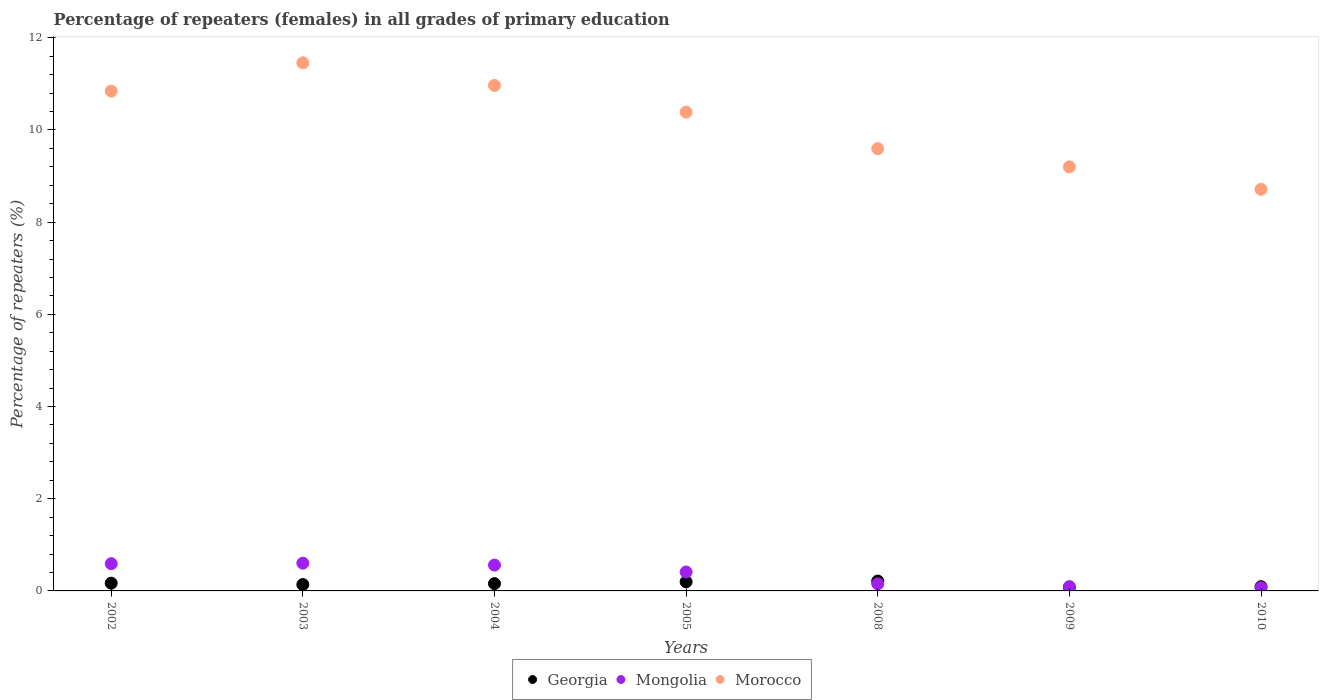Is the number of dotlines equal to the number of legend labels?
Provide a succinct answer. Yes. What is the percentage of repeaters (females) in Mongolia in 2010?
Your answer should be very brief. 0.07. Across all years, what is the maximum percentage of repeaters (females) in Morocco?
Your answer should be very brief. 11.46. Across all years, what is the minimum percentage of repeaters (females) in Georgia?
Your response must be concise. 0.07. What is the total percentage of repeaters (females) in Morocco in the graph?
Your response must be concise. 71.16. What is the difference between the percentage of repeaters (females) in Mongolia in 2005 and that in 2009?
Give a very brief answer. 0.32. What is the difference between the percentage of repeaters (females) in Mongolia in 2005 and the percentage of repeaters (females) in Georgia in 2010?
Offer a terse response. 0.32. What is the average percentage of repeaters (females) in Mongolia per year?
Make the answer very short. 0.35. In the year 2005, what is the difference between the percentage of repeaters (females) in Morocco and percentage of repeaters (females) in Mongolia?
Offer a terse response. 9.98. In how many years, is the percentage of repeaters (females) in Mongolia greater than 8.8 %?
Keep it short and to the point. 0. What is the ratio of the percentage of repeaters (females) in Morocco in 2002 to that in 2010?
Offer a very short reply. 1.24. Is the difference between the percentage of repeaters (females) in Morocco in 2004 and 2010 greater than the difference between the percentage of repeaters (females) in Mongolia in 2004 and 2010?
Your response must be concise. Yes. What is the difference between the highest and the second highest percentage of repeaters (females) in Mongolia?
Offer a very short reply. 0.01. What is the difference between the highest and the lowest percentage of repeaters (females) in Mongolia?
Make the answer very short. 0.53. Does the percentage of repeaters (females) in Georgia monotonically increase over the years?
Give a very brief answer. No. Is the percentage of repeaters (females) in Mongolia strictly less than the percentage of repeaters (females) in Georgia over the years?
Offer a terse response. No. How many dotlines are there?
Offer a terse response. 3. How many years are there in the graph?
Your answer should be very brief. 7. Does the graph contain any zero values?
Offer a very short reply. No. How many legend labels are there?
Offer a terse response. 3. What is the title of the graph?
Your answer should be very brief. Percentage of repeaters (females) in all grades of primary education. Does "Iraq" appear as one of the legend labels in the graph?
Provide a short and direct response. No. What is the label or title of the Y-axis?
Your response must be concise. Percentage of repeaters (%). What is the Percentage of repeaters (%) of Georgia in 2002?
Your response must be concise. 0.17. What is the Percentage of repeaters (%) in Mongolia in 2002?
Offer a very short reply. 0.59. What is the Percentage of repeaters (%) of Morocco in 2002?
Provide a succinct answer. 10.84. What is the Percentage of repeaters (%) in Georgia in 2003?
Give a very brief answer. 0.14. What is the Percentage of repeaters (%) of Mongolia in 2003?
Offer a terse response. 0.6. What is the Percentage of repeaters (%) of Morocco in 2003?
Provide a succinct answer. 11.46. What is the Percentage of repeaters (%) in Georgia in 2004?
Offer a very short reply. 0.16. What is the Percentage of repeaters (%) of Mongolia in 2004?
Provide a succinct answer. 0.56. What is the Percentage of repeaters (%) of Morocco in 2004?
Offer a very short reply. 10.97. What is the Percentage of repeaters (%) in Georgia in 2005?
Your answer should be very brief. 0.2. What is the Percentage of repeaters (%) of Mongolia in 2005?
Provide a short and direct response. 0.41. What is the Percentage of repeaters (%) of Morocco in 2005?
Provide a succinct answer. 10.39. What is the Percentage of repeaters (%) in Georgia in 2008?
Your answer should be compact. 0.21. What is the Percentage of repeaters (%) in Mongolia in 2008?
Ensure brevity in your answer.  0.15. What is the Percentage of repeaters (%) of Morocco in 2008?
Give a very brief answer. 9.6. What is the Percentage of repeaters (%) of Georgia in 2009?
Offer a terse response. 0.07. What is the Percentage of repeaters (%) of Mongolia in 2009?
Your answer should be very brief. 0.09. What is the Percentage of repeaters (%) of Morocco in 2009?
Your response must be concise. 9.2. What is the Percentage of repeaters (%) in Georgia in 2010?
Offer a terse response. 0.09. What is the Percentage of repeaters (%) of Mongolia in 2010?
Ensure brevity in your answer.  0.07. What is the Percentage of repeaters (%) of Morocco in 2010?
Offer a very short reply. 8.71. Across all years, what is the maximum Percentage of repeaters (%) of Georgia?
Keep it short and to the point. 0.21. Across all years, what is the maximum Percentage of repeaters (%) of Mongolia?
Provide a succinct answer. 0.6. Across all years, what is the maximum Percentage of repeaters (%) in Morocco?
Provide a succinct answer. 11.46. Across all years, what is the minimum Percentage of repeaters (%) of Georgia?
Your response must be concise. 0.07. Across all years, what is the minimum Percentage of repeaters (%) of Mongolia?
Offer a terse response. 0.07. Across all years, what is the minimum Percentage of repeaters (%) of Morocco?
Keep it short and to the point. 8.71. What is the total Percentage of repeaters (%) of Georgia in the graph?
Give a very brief answer. 1.04. What is the total Percentage of repeaters (%) in Mongolia in the graph?
Give a very brief answer. 2.48. What is the total Percentage of repeaters (%) of Morocco in the graph?
Make the answer very short. 71.16. What is the difference between the Percentage of repeaters (%) in Georgia in 2002 and that in 2003?
Provide a short and direct response. 0.03. What is the difference between the Percentage of repeaters (%) in Mongolia in 2002 and that in 2003?
Your answer should be compact. -0.01. What is the difference between the Percentage of repeaters (%) in Morocco in 2002 and that in 2003?
Offer a very short reply. -0.61. What is the difference between the Percentage of repeaters (%) of Mongolia in 2002 and that in 2004?
Make the answer very short. 0.03. What is the difference between the Percentage of repeaters (%) in Morocco in 2002 and that in 2004?
Your answer should be very brief. -0.12. What is the difference between the Percentage of repeaters (%) in Georgia in 2002 and that in 2005?
Ensure brevity in your answer.  -0.03. What is the difference between the Percentage of repeaters (%) in Mongolia in 2002 and that in 2005?
Provide a short and direct response. 0.18. What is the difference between the Percentage of repeaters (%) in Morocco in 2002 and that in 2005?
Offer a very short reply. 0.46. What is the difference between the Percentage of repeaters (%) in Georgia in 2002 and that in 2008?
Offer a terse response. -0.05. What is the difference between the Percentage of repeaters (%) in Mongolia in 2002 and that in 2008?
Provide a succinct answer. 0.44. What is the difference between the Percentage of repeaters (%) of Morocco in 2002 and that in 2008?
Give a very brief answer. 1.25. What is the difference between the Percentage of repeaters (%) of Georgia in 2002 and that in 2009?
Your response must be concise. 0.09. What is the difference between the Percentage of repeaters (%) in Mongolia in 2002 and that in 2009?
Provide a short and direct response. 0.5. What is the difference between the Percentage of repeaters (%) of Morocco in 2002 and that in 2009?
Your answer should be very brief. 1.64. What is the difference between the Percentage of repeaters (%) in Georgia in 2002 and that in 2010?
Give a very brief answer. 0.08. What is the difference between the Percentage of repeaters (%) in Mongolia in 2002 and that in 2010?
Offer a terse response. 0.52. What is the difference between the Percentage of repeaters (%) of Morocco in 2002 and that in 2010?
Keep it short and to the point. 2.13. What is the difference between the Percentage of repeaters (%) of Georgia in 2003 and that in 2004?
Make the answer very short. -0.02. What is the difference between the Percentage of repeaters (%) in Mongolia in 2003 and that in 2004?
Offer a very short reply. 0.04. What is the difference between the Percentage of repeaters (%) in Morocco in 2003 and that in 2004?
Provide a short and direct response. 0.49. What is the difference between the Percentage of repeaters (%) of Georgia in 2003 and that in 2005?
Provide a succinct answer. -0.06. What is the difference between the Percentage of repeaters (%) of Mongolia in 2003 and that in 2005?
Offer a very short reply. 0.19. What is the difference between the Percentage of repeaters (%) of Morocco in 2003 and that in 2005?
Your response must be concise. 1.07. What is the difference between the Percentage of repeaters (%) in Georgia in 2003 and that in 2008?
Ensure brevity in your answer.  -0.08. What is the difference between the Percentage of repeaters (%) of Mongolia in 2003 and that in 2008?
Ensure brevity in your answer.  0.45. What is the difference between the Percentage of repeaters (%) of Morocco in 2003 and that in 2008?
Your answer should be very brief. 1.86. What is the difference between the Percentage of repeaters (%) of Georgia in 2003 and that in 2009?
Make the answer very short. 0.06. What is the difference between the Percentage of repeaters (%) of Mongolia in 2003 and that in 2009?
Offer a very short reply. 0.51. What is the difference between the Percentage of repeaters (%) of Morocco in 2003 and that in 2009?
Offer a very short reply. 2.26. What is the difference between the Percentage of repeaters (%) of Georgia in 2003 and that in 2010?
Offer a very short reply. 0.05. What is the difference between the Percentage of repeaters (%) of Mongolia in 2003 and that in 2010?
Ensure brevity in your answer.  0.53. What is the difference between the Percentage of repeaters (%) of Morocco in 2003 and that in 2010?
Make the answer very short. 2.74. What is the difference between the Percentage of repeaters (%) of Georgia in 2004 and that in 2005?
Give a very brief answer. -0.04. What is the difference between the Percentage of repeaters (%) of Mongolia in 2004 and that in 2005?
Keep it short and to the point. 0.15. What is the difference between the Percentage of repeaters (%) of Morocco in 2004 and that in 2005?
Offer a terse response. 0.58. What is the difference between the Percentage of repeaters (%) of Georgia in 2004 and that in 2008?
Ensure brevity in your answer.  -0.06. What is the difference between the Percentage of repeaters (%) in Mongolia in 2004 and that in 2008?
Your response must be concise. 0.41. What is the difference between the Percentage of repeaters (%) of Morocco in 2004 and that in 2008?
Your response must be concise. 1.37. What is the difference between the Percentage of repeaters (%) in Georgia in 2004 and that in 2009?
Your answer should be compact. 0.08. What is the difference between the Percentage of repeaters (%) in Mongolia in 2004 and that in 2009?
Your answer should be very brief. 0.47. What is the difference between the Percentage of repeaters (%) in Morocco in 2004 and that in 2009?
Your answer should be compact. 1.77. What is the difference between the Percentage of repeaters (%) of Georgia in 2004 and that in 2010?
Keep it short and to the point. 0.07. What is the difference between the Percentage of repeaters (%) of Mongolia in 2004 and that in 2010?
Provide a short and direct response. 0.49. What is the difference between the Percentage of repeaters (%) of Morocco in 2004 and that in 2010?
Offer a very short reply. 2.25. What is the difference between the Percentage of repeaters (%) in Georgia in 2005 and that in 2008?
Keep it short and to the point. -0.02. What is the difference between the Percentage of repeaters (%) in Mongolia in 2005 and that in 2008?
Make the answer very short. 0.26. What is the difference between the Percentage of repeaters (%) of Morocco in 2005 and that in 2008?
Give a very brief answer. 0.79. What is the difference between the Percentage of repeaters (%) of Georgia in 2005 and that in 2009?
Provide a succinct answer. 0.12. What is the difference between the Percentage of repeaters (%) of Mongolia in 2005 and that in 2009?
Offer a terse response. 0.32. What is the difference between the Percentage of repeaters (%) of Morocco in 2005 and that in 2009?
Your response must be concise. 1.19. What is the difference between the Percentage of repeaters (%) in Georgia in 2005 and that in 2010?
Give a very brief answer. 0.11. What is the difference between the Percentage of repeaters (%) in Mongolia in 2005 and that in 2010?
Your answer should be compact. 0.34. What is the difference between the Percentage of repeaters (%) of Morocco in 2005 and that in 2010?
Offer a very short reply. 1.67. What is the difference between the Percentage of repeaters (%) of Georgia in 2008 and that in 2009?
Your response must be concise. 0.14. What is the difference between the Percentage of repeaters (%) in Mongolia in 2008 and that in 2009?
Keep it short and to the point. 0.06. What is the difference between the Percentage of repeaters (%) of Morocco in 2008 and that in 2009?
Ensure brevity in your answer.  0.4. What is the difference between the Percentage of repeaters (%) of Georgia in 2008 and that in 2010?
Make the answer very short. 0.12. What is the difference between the Percentage of repeaters (%) of Mongolia in 2008 and that in 2010?
Your answer should be compact. 0.08. What is the difference between the Percentage of repeaters (%) in Morocco in 2008 and that in 2010?
Your response must be concise. 0.88. What is the difference between the Percentage of repeaters (%) of Georgia in 2009 and that in 2010?
Your response must be concise. -0.02. What is the difference between the Percentage of repeaters (%) in Mongolia in 2009 and that in 2010?
Offer a terse response. 0.03. What is the difference between the Percentage of repeaters (%) of Morocco in 2009 and that in 2010?
Your answer should be very brief. 0.49. What is the difference between the Percentage of repeaters (%) in Georgia in 2002 and the Percentage of repeaters (%) in Mongolia in 2003?
Make the answer very short. -0.43. What is the difference between the Percentage of repeaters (%) of Georgia in 2002 and the Percentage of repeaters (%) of Morocco in 2003?
Keep it short and to the point. -11.29. What is the difference between the Percentage of repeaters (%) of Mongolia in 2002 and the Percentage of repeaters (%) of Morocco in 2003?
Provide a short and direct response. -10.86. What is the difference between the Percentage of repeaters (%) in Georgia in 2002 and the Percentage of repeaters (%) in Mongolia in 2004?
Give a very brief answer. -0.39. What is the difference between the Percentage of repeaters (%) in Georgia in 2002 and the Percentage of repeaters (%) in Morocco in 2004?
Keep it short and to the point. -10.8. What is the difference between the Percentage of repeaters (%) in Mongolia in 2002 and the Percentage of repeaters (%) in Morocco in 2004?
Offer a very short reply. -10.37. What is the difference between the Percentage of repeaters (%) of Georgia in 2002 and the Percentage of repeaters (%) of Mongolia in 2005?
Provide a succinct answer. -0.24. What is the difference between the Percentage of repeaters (%) in Georgia in 2002 and the Percentage of repeaters (%) in Morocco in 2005?
Your answer should be very brief. -10.22. What is the difference between the Percentage of repeaters (%) of Mongolia in 2002 and the Percentage of repeaters (%) of Morocco in 2005?
Provide a short and direct response. -9.8. What is the difference between the Percentage of repeaters (%) of Georgia in 2002 and the Percentage of repeaters (%) of Mongolia in 2008?
Make the answer very short. 0.01. What is the difference between the Percentage of repeaters (%) of Georgia in 2002 and the Percentage of repeaters (%) of Morocco in 2008?
Your answer should be very brief. -9.43. What is the difference between the Percentage of repeaters (%) in Mongolia in 2002 and the Percentage of repeaters (%) in Morocco in 2008?
Provide a short and direct response. -9. What is the difference between the Percentage of repeaters (%) of Georgia in 2002 and the Percentage of repeaters (%) of Mongolia in 2009?
Give a very brief answer. 0.07. What is the difference between the Percentage of repeaters (%) of Georgia in 2002 and the Percentage of repeaters (%) of Morocco in 2009?
Make the answer very short. -9.03. What is the difference between the Percentage of repeaters (%) in Mongolia in 2002 and the Percentage of repeaters (%) in Morocco in 2009?
Offer a very short reply. -8.61. What is the difference between the Percentage of repeaters (%) of Georgia in 2002 and the Percentage of repeaters (%) of Mongolia in 2010?
Your answer should be compact. 0.1. What is the difference between the Percentage of repeaters (%) of Georgia in 2002 and the Percentage of repeaters (%) of Morocco in 2010?
Provide a short and direct response. -8.54. What is the difference between the Percentage of repeaters (%) of Mongolia in 2002 and the Percentage of repeaters (%) of Morocco in 2010?
Ensure brevity in your answer.  -8.12. What is the difference between the Percentage of repeaters (%) of Georgia in 2003 and the Percentage of repeaters (%) of Mongolia in 2004?
Make the answer very short. -0.42. What is the difference between the Percentage of repeaters (%) of Georgia in 2003 and the Percentage of repeaters (%) of Morocco in 2004?
Your answer should be very brief. -10.83. What is the difference between the Percentage of repeaters (%) in Mongolia in 2003 and the Percentage of repeaters (%) in Morocco in 2004?
Provide a succinct answer. -10.36. What is the difference between the Percentage of repeaters (%) of Georgia in 2003 and the Percentage of repeaters (%) of Mongolia in 2005?
Ensure brevity in your answer.  -0.27. What is the difference between the Percentage of repeaters (%) of Georgia in 2003 and the Percentage of repeaters (%) of Morocco in 2005?
Make the answer very short. -10.25. What is the difference between the Percentage of repeaters (%) in Mongolia in 2003 and the Percentage of repeaters (%) in Morocco in 2005?
Keep it short and to the point. -9.78. What is the difference between the Percentage of repeaters (%) in Georgia in 2003 and the Percentage of repeaters (%) in Mongolia in 2008?
Ensure brevity in your answer.  -0.01. What is the difference between the Percentage of repeaters (%) of Georgia in 2003 and the Percentage of repeaters (%) of Morocco in 2008?
Give a very brief answer. -9.46. What is the difference between the Percentage of repeaters (%) of Mongolia in 2003 and the Percentage of repeaters (%) of Morocco in 2008?
Make the answer very short. -8.99. What is the difference between the Percentage of repeaters (%) of Georgia in 2003 and the Percentage of repeaters (%) of Mongolia in 2009?
Your answer should be compact. 0.04. What is the difference between the Percentage of repeaters (%) in Georgia in 2003 and the Percentage of repeaters (%) in Morocco in 2009?
Offer a terse response. -9.06. What is the difference between the Percentage of repeaters (%) of Mongolia in 2003 and the Percentage of repeaters (%) of Morocco in 2009?
Offer a terse response. -8.6. What is the difference between the Percentage of repeaters (%) of Georgia in 2003 and the Percentage of repeaters (%) of Mongolia in 2010?
Your answer should be compact. 0.07. What is the difference between the Percentage of repeaters (%) in Georgia in 2003 and the Percentage of repeaters (%) in Morocco in 2010?
Keep it short and to the point. -8.57. What is the difference between the Percentage of repeaters (%) of Mongolia in 2003 and the Percentage of repeaters (%) of Morocco in 2010?
Ensure brevity in your answer.  -8.11. What is the difference between the Percentage of repeaters (%) in Georgia in 2004 and the Percentage of repeaters (%) in Mongolia in 2005?
Provide a succinct answer. -0.25. What is the difference between the Percentage of repeaters (%) of Georgia in 2004 and the Percentage of repeaters (%) of Morocco in 2005?
Your response must be concise. -10.23. What is the difference between the Percentage of repeaters (%) in Mongolia in 2004 and the Percentage of repeaters (%) in Morocco in 2005?
Provide a short and direct response. -9.83. What is the difference between the Percentage of repeaters (%) in Georgia in 2004 and the Percentage of repeaters (%) in Mongolia in 2008?
Give a very brief answer. 0.01. What is the difference between the Percentage of repeaters (%) in Georgia in 2004 and the Percentage of repeaters (%) in Morocco in 2008?
Offer a terse response. -9.44. What is the difference between the Percentage of repeaters (%) in Mongolia in 2004 and the Percentage of repeaters (%) in Morocco in 2008?
Make the answer very short. -9.03. What is the difference between the Percentage of repeaters (%) in Georgia in 2004 and the Percentage of repeaters (%) in Mongolia in 2009?
Your response must be concise. 0.06. What is the difference between the Percentage of repeaters (%) of Georgia in 2004 and the Percentage of repeaters (%) of Morocco in 2009?
Your answer should be compact. -9.04. What is the difference between the Percentage of repeaters (%) of Mongolia in 2004 and the Percentage of repeaters (%) of Morocco in 2009?
Provide a short and direct response. -8.64. What is the difference between the Percentage of repeaters (%) in Georgia in 2004 and the Percentage of repeaters (%) in Mongolia in 2010?
Give a very brief answer. 0.09. What is the difference between the Percentage of repeaters (%) in Georgia in 2004 and the Percentage of repeaters (%) in Morocco in 2010?
Keep it short and to the point. -8.55. What is the difference between the Percentage of repeaters (%) of Mongolia in 2004 and the Percentage of repeaters (%) of Morocco in 2010?
Provide a short and direct response. -8.15. What is the difference between the Percentage of repeaters (%) in Georgia in 2005 and the Percentage of repeaters (%) in Mongolia in 2008?
Make the answer very short. 0.04. What is the difference between the Percentage of repeaters (%) of Georgia in 2005 and the Percentage of repeaters (%) of Morocco in 2008?
Keep it short and to the point. -9.4. What is the difference between the Percentage of repeaters (%) of Mongolia in 2005 and the Percentage of repeaters (%) of Morocco in 2008?
Keep it short and to the point. -9.18. What is the difference between the Percentage of repeaters (%) in Georgia in 2005 and the Percentage of repeaters (%) in Mongolia in 2009?
Make the answer very short. 0.1. What is the difference between the Percentage of repeaters (%) of Georgia in 2005 and the Percentage of repeaters (%) of Morocco in 2009?
Provide a short and direct response. -9. What is the difference between the Percentage of repeaters (%) of Mongolia in 2005 and the Percentage of repeaters (%) of Morocco in 2009?
Your answer should be very brief. -8.79. What is the difference between the Percentage of repeaters (%) in Georgia in 2005 and the Percentage of repeaters (%) in Mongolia in 2010?
Offer a very short reply. 0.13. What is the difference between the Percentage of repeaters (%) of Georgia in 2005 and the Percentage of repeaters (%) of Morocco in 2010?
Ensure brevity in your answer.  -8.51. What is the difference between the Percentage of repeaters (%) in Mongolia in 2005 and the Percentage of repeaters (%) in Morocco in 2010?
Your response must be concise. -8.3. What is the difference between the Percentage of repeaters (%) in Georgia in 2008 and the Percentage of repeaters (%) in Mongolia in 2009?
Your answer should be very brief. 0.12. What is the difference between the Percentage of repeaters (%) in Georgia in 2008 and the Percentage of repeaters (%) in Morocco in 2009?
Your response must be concise. -8.99. What is the difference between the Percentage of repeaters (%) of Mongolia in 2008 and the Percentage of repeaters (%) of Morocco in 2009?
Provide a short and direct response. -9.05. What is the difference between the Percentage of repeaters (%) of Georgia in 2008 and the Percentage of repeaters (%) of Mongolia in 2010?
Offer a very short reply. 0.15. What is the difference between the Percentage of repeaters (%) in Georgia in 2008 and the Percentage of repeaters (%) in Morocco in 2010?
Keep it short and to the point. -8.5. What is the difference between the Percentage of repeaters (%) in Mongolia in 2008 and the Percentage of repeaters (%) in Morocco in 2010?
Give a very brief answer. -8.56. What is the difference between the Percentage of repeaters (%) of Georgia in 2009 and the Percentage of repeaters (%) of Mongolia in 2010?
Keep it short and to the point. 0.01. What is the difference between the Percentage of repeaters (%) of Georgia in 2009 and the Percentage of repeaters (%) of Morocco in 2010?
Make the answer very short. -8.64. What is the difference between the Percentage of repeaters (%) of Mongolia in 2009 and the Percentage of repeaters (%) of Morocco in 2010?
Offer a very short reply. -8.62. What is the average Percentage of repeaters (%) of Georgia per year?
Provide a succinct answer. 0.15. What is the average Percentage of repeaters (%) in Mongolia per year?
Your response must be concise. 0.35. What is the average Percentage of repeaters (%) in Morocco per year?
Your answer should be very brief. 10.17. In the year 2002, what is the difference between the Percentage of repeaters (%) of Georgia and Percentage of repeaters (%) of Mongolia?
Make the answer very short. -0.42. In the year 2002, what is the difference between the Percentage of repeaters (%) in Georgia and Percentage of repeaters (%) in Morocco?
Offer a terse response. -10.67. In the year 2002, what is the difference between the Percentage of repeaters (%) in Mongolia and Percentage of repeaters (%) in Morocco?
Ensure brevity in your answer.  -10.25. In the year 2003, what is the difference between the Percentage of repeaters (%) of Georgia and Percentage of repeaters (%) of Mongolia?
Ensure brevity in your answer.  -0.46. In the year 2003, what is the difference between the Percentage of repeaters (%) in Georgia and Percentage of repeaters (%) in Morocco?
Provide a succinct answer. -11.32. In the year 2003, what is the difference between the Percentage of repeaters (%) in Mongolia and Percentage of repeaters (%) in Morocco?
Your response must be concise. -10.85. In the year 2004, what is the difference between the Percentage of repeaters (%) of Georgia and Percentage of repeaters (%) of Mongolia?
Make the answer very short. -0.4. In the year 2004, what is the difference between the Percentage of repeaters (%) in Georgia and Percentage of repeaters (%) in Morocco?
Your response must be concise. -10.81. In the year 2004, what is the difference between the Percentage of repeaters (%) of Mongolia and Percentage of repeaters (%) of Morocco?
Offer a terse response. -10.41. In the year 2005, what is the difference between the Percentage of repeaters (%) in Georgia and Percentage of repeaters (%) in Mongolia?
Keep it short and to the point. -0.21. In the year 2005, what is the difference between the Percentage of repeaters (%) of Georgia and Percentage of repeaters (%) of Morocco?
Make the answer very short. -10.19. In the year 2005, what is the difference between the Percentage of repeaters (%) of Mongolia and Percentage of repeaters (%) of Morocco?
Offer a terse response. -9.98. In the year 2008, what is the difference between the Percentage of repeaters (%) in Georgia and Percentage of repeaters (%) in Mongolia?
Offer a terse response. 0.06. In the year 2008, what is the difference between the Percentage of repeaters (%) of Georgia and Percentage of repeaters (%) of Morocco?
Your answer should be very brief. -9.38. In the year 2008, what is the difference between the Percentage of repeaters (%) in Mongolia and Percentage of repeaters (%) in Morocco?
Your answer should be compact. -9.44. In the year 2009, what is the difference between the Percentage of repeaters (%) in Georgia and Percentage of repeaters (%) in Mongolia?
Your answer should be very brief. -0.02. In the year 2009, what is the difference between the Percentage of repeaters (%) of Georgia and Percentage of repeaters (%) of Morocco?
Make the answer very short. -9.12. In the year 2009, what is the difference between the Percentage of repeaters (%) of Mongolia and Percentage of repeaters (%) of Morocco?
Give a very brief answer. -9.1. In the year 2010, what is the difference between the Percentage of repeaters (%) in Georgia and Percentage of repeaters (%) in Mongolia?
Offer a very short reply. 0.02. In the year 2010, what is the difference between the Percentage of repeaters (%) in Georgia and Percentage of repeaters (%) in Morocco?
Provide a succinct answer. -8.62. In the year 2010, what is the difference between the Percentage of repeaters (%) in Mongolia and Percentage of repeaters (%) in Morocco?
Ensure brevity in your answer.  -8.64. What is the ratio of the Percentage of repeaters (%) in Georgia in 2002 to that in 2003?
Your answer should be compact. 1.22. What is the ratio of the Percentage of repeaters (%) in Morocco in 2002 to that in 2003?
Provide a succinct answer. 0.95. What is the ratio of the Percentage of repeaters (%) of Georgia in 2002 to that in 2004?
Offer a very short reply. 1.06. What is the ratio of the Percentage of repeaters (%) of Mongolia in 2002 to that in 2004?
Ensure brevity in your answer.  1.06. What is the ratio of the Percentage of repeaters (%) in Morocco in 2002 to that in 2004?
Offer a terse response. 0.99. What is the ratio of the Percentage of repeaters (%) of Georgia in 2002 to that in 2005?
Your answer should be very brief. 0.85. What is the ratio of the Percentage of repeaters (%) in Mongolia in 2002 to that in 2005?
Provide a succinct answer. 1.44. What is the ratio of the Percentage of repeaters (%) of Morocco in 2002 to that in 2005?
Provide a short and direct response. 1.04. What is the ratio of the Percentage of repeaters (%) in Georgia in 2002 to that in 2008?
Your answer should be very brief. 0.79. What is the ratio of the Percentage of repeaters (%) of Mongolia in 2002 to that in 2008?
Your answer should be compact. 3.86. What is the ratio of the Percentage of repeaters (%) of Morocco in 2002 to that in 2008?
Offer a very short reply. 1.13. What is the ratio of the Percentage of repeaters (%) of Georgia in 2002 to that in 2009?
Your answer should be very brief. 2.25. What is the ratio of the Percentage of repeaters (%) of Mongolia in 2002 to that in 2009?
Offer a terse response. 6.28. What is the ratio of the Percentage of repeaters (%) in Morocco in 2002 to that in 2009?
Keep it short and to the point. 1.18. What is the ratio of the Percentage of repeaters (%) of Georgia in 2002 to that in 2010?
Make the answer very short. 1.83. What is the ratio of the Percentage of repeaters (%) of Mongolia in 2002 to that in 2010?
Your response must be concise. 8.63. What is the ratio of the Percentage of repeaters (%) of Morocco in 2002 to that in 2010?
Your response must be concise. 1.24. What is the ratio of the Percentage of repeaters (%) in Georgia in 2003 to that in 2004?
Your answer should be compact. 0.87. What is the ratio of the Percentage of repeaters (%) of Mongolia in 2003 to that in 2004?
Offer a terse response. 1.07. What is the ratio of the Percentage of repeaters (%) in Morocco in 2003 to that in 2004?
Give a very brief answer. 1.04. What is the ratio of the Percentage of repeaters (%) of Georgia in 2003 to that in 2005?
Offer a very short reply. 0.7. What is the ratio of the Percentage of repeaters (%) of Mongolia in 2003 to that in 2005?
Your response must be concise. 1.47. What is the ratio of the Percentage of repeaters (%) of Morocco in 2003 to that in 2005?
Keep it short and to the point. 1.1. What is the ratio of the Percentage of repeaters (%) of Georgia in 2003 to that in 2008?
Make the answer very short. 0.65. What is the ratio of the Percentage of repeaters (%) of Mongolia in 2003 to that in 2008?
Ensure brevity in your answer.  3.93. What is the ratio of the Percentage of repeaters (%) of Morocco in 2003 to that in 2008?
Give a very brief answer. 1.19. What is the ratio of the Percentage of repeaters (%) of Georgia in 2003 to that in 2009?
Your response must be concise. 1.85. What is the ratio of the Percentage of repeaters (%) in Mongolia in 2003 to that in 2009?
Offer a very short reply. 6.39. What is the ratio of the Percentage of repeaters (%) in Morocco in 2003 to that in 2009?
Make the answer very short. 1.25. What is the ratio of the Percentage of repeaters (%) in Georgia in 2003 to that in 2010?
Keep it short and to the point. 1.51. What is the ratio of the Percentage of repeaters (%) in Mongolia in 2003 to that in 2010?
Your response must be concise. 8.78. What is the ratio of the Percentage of repeaters (%) in Morocco in 2003 to that in 2010?
Provide a short and direct response. 1.32. What is the ratio of the Percentage of repeaters (%) in Georgia in 2004 to that in 2005?
Ensure brevity in your answer.  0.8. What is the ratio of the Percentage of repeaters (%) in Mongolia in 2004 to that in 2005?
Offer a terse response. 1.37. What is the ratio of the Percentage of repeaters (%) in Morocco in 2004 to that in 2005?
Give a very brief answer. 1.06. What is the ratio of the Percentage of repeaters (%) of Georgia in 2004 to that in 2008?
Offer a very short reply. 0.74. What is the ratio of the Percentage of repeaters (%) in Mongolia in 2004 to that in 2008?
Keep it short and to the point. 3.65. What is the ratio of the Percentage of repeaters (%) in Morocco in 2004 to that in 2008?
Your answer should be very brief. 1.14. What is the ratio of the Percentage of repeaters (%) of Georgia in 2004 to that in 2009?
Offer a terse response. 2.12. What is the ratio of the Percentage of repeaters (%) of Mongolia in 2004 to that in 2009?
Provide a short and direct response. 5.95. What is the ratio of the Percentage of repeaters (%) in Morocco in 2004 to that in 2009?
Your response must be concise. 1.19. What is the ratio of the Percentage of repeaters (%) in Georgia in 2004 to that in 2010?
Ensure brevity in your answer.  1.72. What is the ratio of the Percentage of repeaters (%) of Mongolia in 2004 to that in 2010?
Your answer should be very brief. 8.17. What is the ratio of the Percentage of repeaters (%) of Morocco in 2004 to that in 2010?
Your answer should be compact. 1.26. What is the ratio of the Percentage of repeaters (%) in Georgia in 2005 to that in 2008?
Your answer should be compact. 0.92. What is the ratio of the Percentage of repeaters (%) of Mongolia in 2005 to that in 2008?
Your response must be concise. 2.67. What is the ratio of the Percentage of repeaters (%) in Morocco in 2005 to that in 2008?
Ensure brevity in your answer.  1.08. What is the ratio of the Percentage of repeaters (%) of Georgia in 2005 to that in 2009?
Ensure brevity in your answer.  2.64. What is the ratio of the Percentage of repeaters (%) of Mongolia in 2005 to that in 2009?
Give a very brief answer. 4.35. What is the ratio of the Percentage of repeaters (%) in Morocco in 2005 to that in 2009?
Make the answer very short. 1.13. What is the ratio of the Percentage of repeaters (%) in Georgia in 2005 to that in 2010?
Give a very brief answer. 2.15. What is the ratio of the Percentage of repeaters (%) in Mongolia in 2005 to that in 2010?
Your answer should be very brief. 5.98. What is the ratio of the Percentage of repeaters (%) of Morocco in 2005 to that in 2010?
Offer a terse response. 1.19. What is the ratio of the Percentage of repeaters (%) in Georgia in 2008 to that in 2009?
Offer a very short reply. 2.86. What is the ratio of the Percentage of repeaters (%) of Mongolia in 2008 to that in 2009?
Provide a short and direct response. 1.63. What is the ratio of the Percentage of repeaters (%) of Morocco in 2008 to that in 2009?
Provide a short and direct response. 1.04. What is the ratio of the Percentage of repeaters (%) of Georgia in 2008 to that in 2010?
Keep it short and to the point. 2.33. What is the ratio of the Percentage of repeaters (%) of Mongolia in 2008 to that in 2010?
Keep it short and to the point. 2.24. What is the ratio of the Percentage of repeaters (%) in Morocco in 2008 to that in 2010?
Provide a succinct answer. 1.1. What is the ratio of the Percentage of repeaters (%) of Georgia in 2009 to that in 2010?
Keep it short and to the point. 0.81. What is the ratio of the Percentage of repeaters (%) of Mongolia in 2009 to that in 2010?
Give a very brief answer. 1.37. What is the ratio of the Percentage of repeaters (%) in Morocco in 2009 to that in 2010?
Your response must be concise. 1.06. What is the difference between the highest and the second highest Percentage of repeaters (%) of Georgia?
Your answer should be compact. 0.02. What is the difference between the highest and the second highest Percentage of repeaters (%) in Mongolia?
Your answer should be very brief. 0.01. What is the difference between the highest and the second highest Percentage of repeaters (%) of Morocco?
Ensure brevity in your answer.  0.49. What is the difference between the highest and the lowest Percentage of repeaters (%) in Georgia?
Ensure brevity in your answer.  0.14. What is the difference between the highest and the lowest Percentage of repeaters (%) in Mongolia?
Offer a terse response. 0.53. What is the difference between the highest and the lowest Percentage of repeaters (%) in Morocco?
Your answer should be very brief. 2.74. 